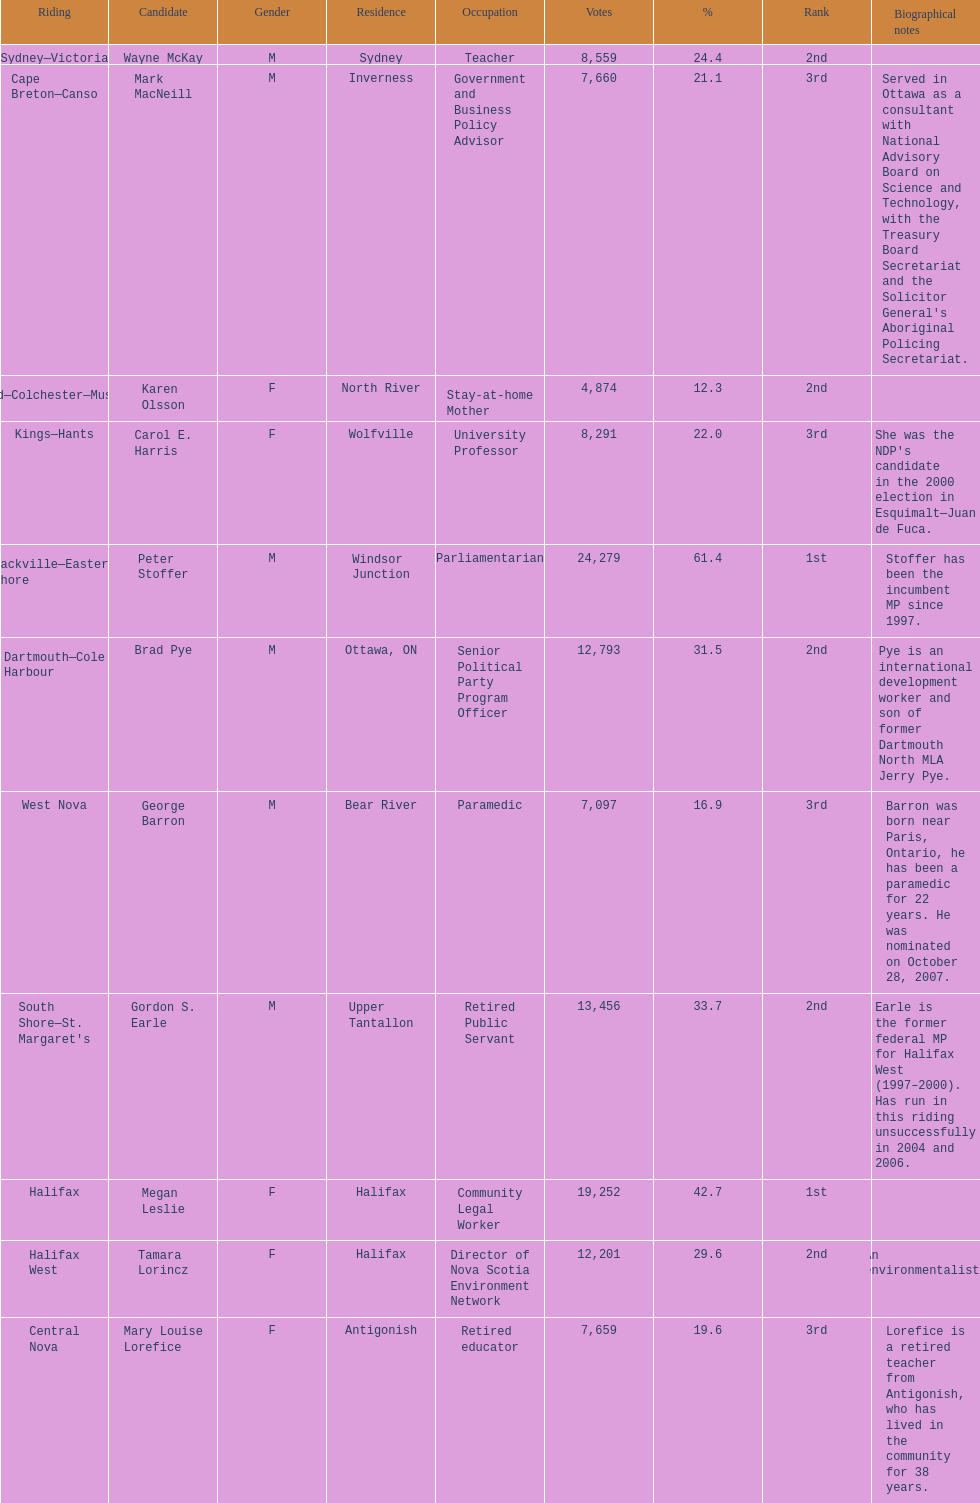What is the number of votes that megan leslie received? 19,252. I'm looking to parse the entire table for insights. Could you assist me with that? {'header': ['Riding', 'Candidate', 'Gender', 'Residence', 'Occupation', 'Votes', '%', 'Rank', 'Biographical notes'], 'rows': [['Sydney—Victoria', 'Wayne McKay', 'M', 'Sydney', 'Teacher', '8,559', '24.4', '2nd', ''], ['Cape Breton—Canso', 'Mark MacNeill', 'M', 'Inverness', 'Government and Business Policy Advisor', '7,660', '21.1', '3rd', "Served in Ottawa as a consultant with National Advisory Board on Science and Technology, with the Treasury Board Secretariat and the Solicitor General's Aboriginal Policing Secretariat."], ['Cumberland—Colchester—Musquodoboit Valley', 'Karen Olsson', 'F', 'North River', 'Stay-at-home Mother', '4,874', '12.3', '2nd', ''], ['Kings—Hants', 'Carol E. Harris', 'F', 'Wolfville', 'University Professor', '8,291', '22.0', '3rd', "She was the NDP's candidate in the 2000 election in Esquimalt—Juan de Fuca."], ['Sackville—Eastern Shore', 'Peter Stoffer', 'M', 'Windsor Junction', 'Parliamentarian', '24,279', '61.4', '1st', 'Stoffer has been the incumbent MP since 1997.'], ['Dartmouth—Cole Harbour', 'Brad Pye', 'M', 'Ottawa, ON', 'Senior Political Party Program Officer', '12,793', '31.5', '2nd', 'Pye is an international development worker and son of former Dartmouth North MLA Jerry Pye.'], ['West Nova', 'George Barron', 'M', 'Bear River', 'Paramedic', '7,097', '16.9', '3rd', 'Barron was born near Paris, Ontario, he has been a paramedic for 22 years. He was nominated on October 28, 2007.'], ["South Shore—St. Margaret's", 'Gordon S. Earle', 'M', 'Upper Tantallon', 'Retired Public Servant', '13,456', '33.7', '2nd', 'Earle is the former federal MP for Halifax West (1997–2000). Has run in this riding unsuccessfully in 2004 and 2006.'], ['Halifax', 'Megan Leslie', 'F', 'Halifax', 'Community Legal Worker', '19,252', '42.7', '1st', ''], ['Halifax West', 'Tamara Lorincz', 'F', 'Halifax', 'Director of Nova Scotia Environment Network', '12,201', '29.6', '2nd', 'An environmentalist.'], ['Central Nova', 'Mary Louise Lorefice', 'F', 'Antigonish', 'Retired educator', '7,659', '19.6', '3rd', 'Lorefice is a retired teacher from Antigonish, who has lived in the community for 38 years.']]} 